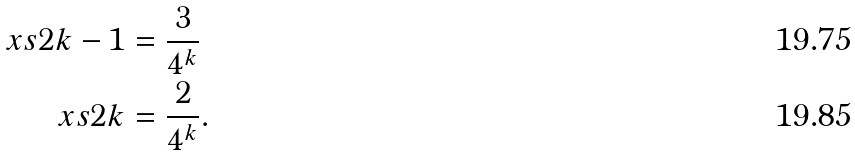<formula> <loc_0><loc_0><loc_500><loc_500>\ x s { 2 k - 1 } & = \frac { 3 } { 4 ^ { k } } \\ \ x s { 2 k } & = \frac { 2 } { 4 ^ { k } } .</formula> 